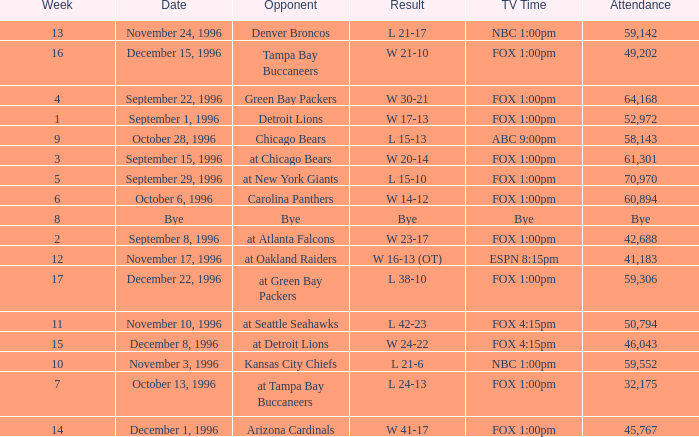Tell me the opponent for november 24, 1996 Denver Broncos. 